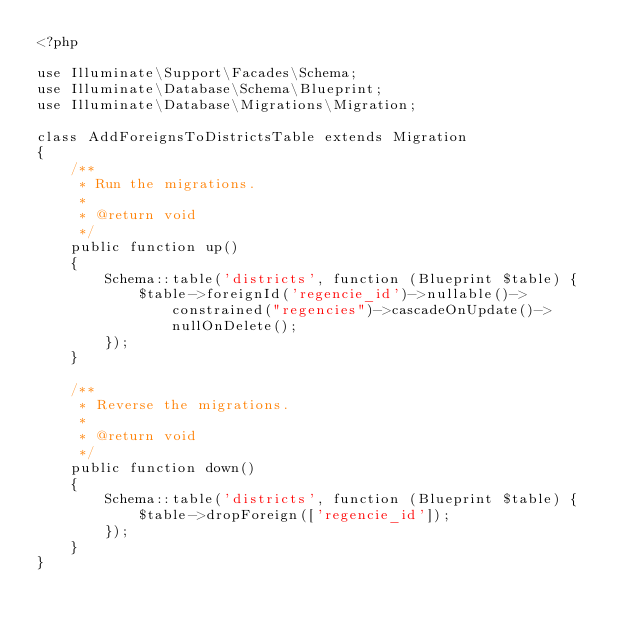Convert code to text. <code><loc_0><loc_0><loc_500><loc_500><_PHP_><?php

use Illuminate\Support\Facades\Schema;
use Illuminate\Database\Schema\Blueprint;
use Illuminate\Database\Migrations\Migration;

class AddForeignsToDistrictsTable extends Migration
{
    /**
     * Run the migrations.
     *
     * @return void
     */
    public function up()
    {
        Schema::table('districts', function (Blueprint $table) {
            $table->foreignId('regencie_id')->nullable()->constrained("regencies")->cascadeOnUpdate()->nullOnDelete();
        });
    }

    /**
     * Reverse the migrations.
     *
     * @return void
     */
    public function down()
    {
        Schema::table('districts', function (Blueprint $table) {
            $table->dropForeign(['regencie_id']);
        });
    }
}
</code> 